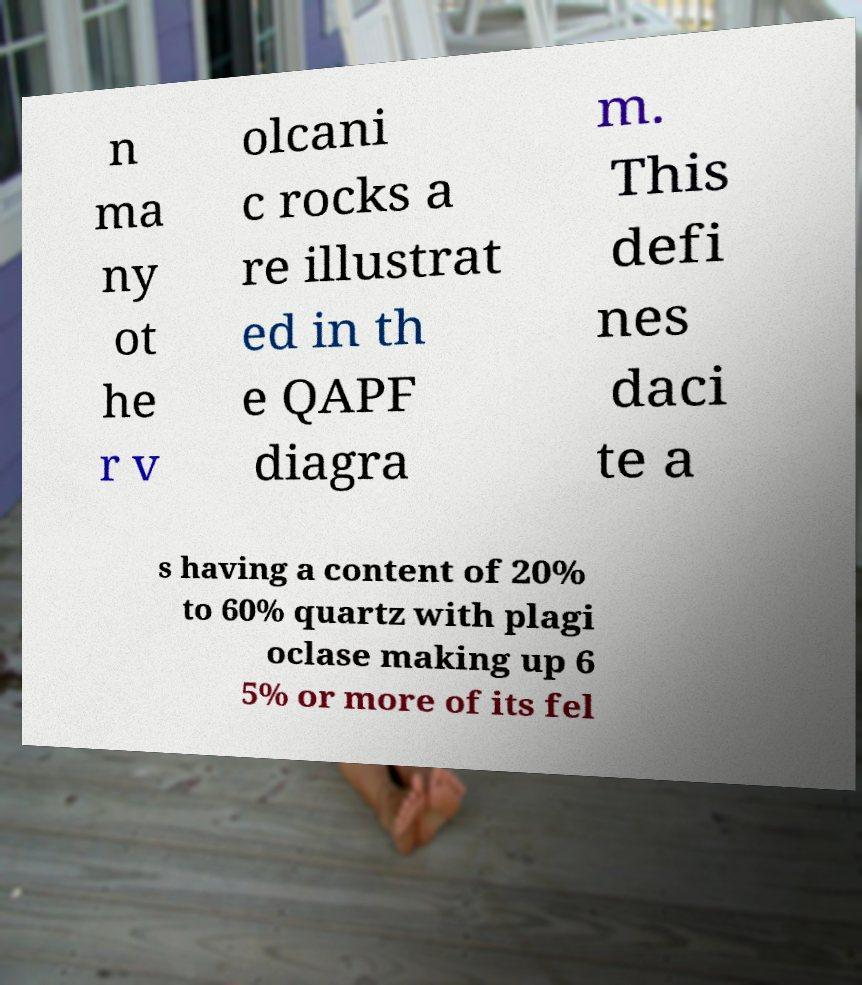Can you read and provide the text displayed in the image?This photo seems to have some interesting text. Can you extract and type it out for me? n ma ny ot he r v olcani c rocks a re illustrat ed in th e QAPF diagra m. This defi nes daci te a s having a content of 20% to 60% quartz with plagi oclase making up 6 5% or more of its fel 